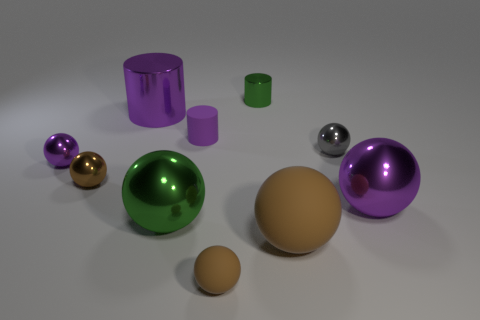There is a matte sphere that is the same size as the gray shiny thing; what color is it?
Keep it short and to the point. Brown. Does the tiny green object have the same shape as the purple matte thing?
Give a very brief answer. Yes. There is a small brown object that is behind the big brown matte ball; what material is it?
Your answer should be compact. Metal. The big matte thing is what color?
Give a very brief answer. Brown. There is a purple cylinder to the right of the green ball; is it the same size as the purple sphere left of the tiny gray shiny sphere?
Provide a short and direct response. Yes. There is a object that is to the right of the small purple metal object and on the left side of the large purple metal cylinder; what size is it?
Provide a succinct answer. Small. The small matte thing that is the same shape as the brown metal object is what color?
Offer a very short reply. Brown. Is the number of small brown rubber balls in front of the tiny shiny cylinder greater than the number of purple matte cylinders that are in front of the gray shiny sphere?
Offer a very short reply. Yes. How many other things are there of the same shape as the small brown metal object?
Offer a terse response. 6. Are there any purple shiny objects in front of the tiny shiny ball on the right side of the green metal cylinder?
Provide a succinct answer. Yes. 